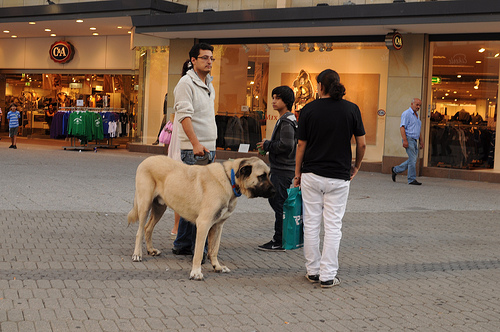What color do you think the shirt the woman is wearing has? The color of the shirt the woman is wearing appears to be black, which offers a versatile look in the casual setting. 